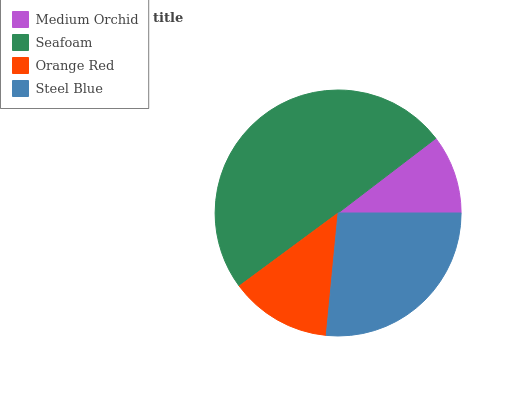Is Medium Orchid the minimum?
Answer yes or no. Yes. Is Seafoam the maximum?
Answer yes or no. Yes. Is Orange Red the minimum?
Answer yes or no. No. Is Orange Red the maximum?
Answer yes or no. No. Is Seafoam greater than Orange Red?
Answer yes or no. Yes. Is Orange Red less than Seafoam?
Answer yes or no. Yes. Is Orange Red greater than Seafoam?
Answer yes or no. No. Is Seafoam less than Orange Red?
Answer yes or no. No. Is Steel Blue the high median?
Answer yes or no. Yes. Is Orange Red the low median?
Answer yes or no. Yes. Is Medium Orchid the high median?
Answer yes or no. No. Is Steel Blue the low median?
Answer yes or no. No. 